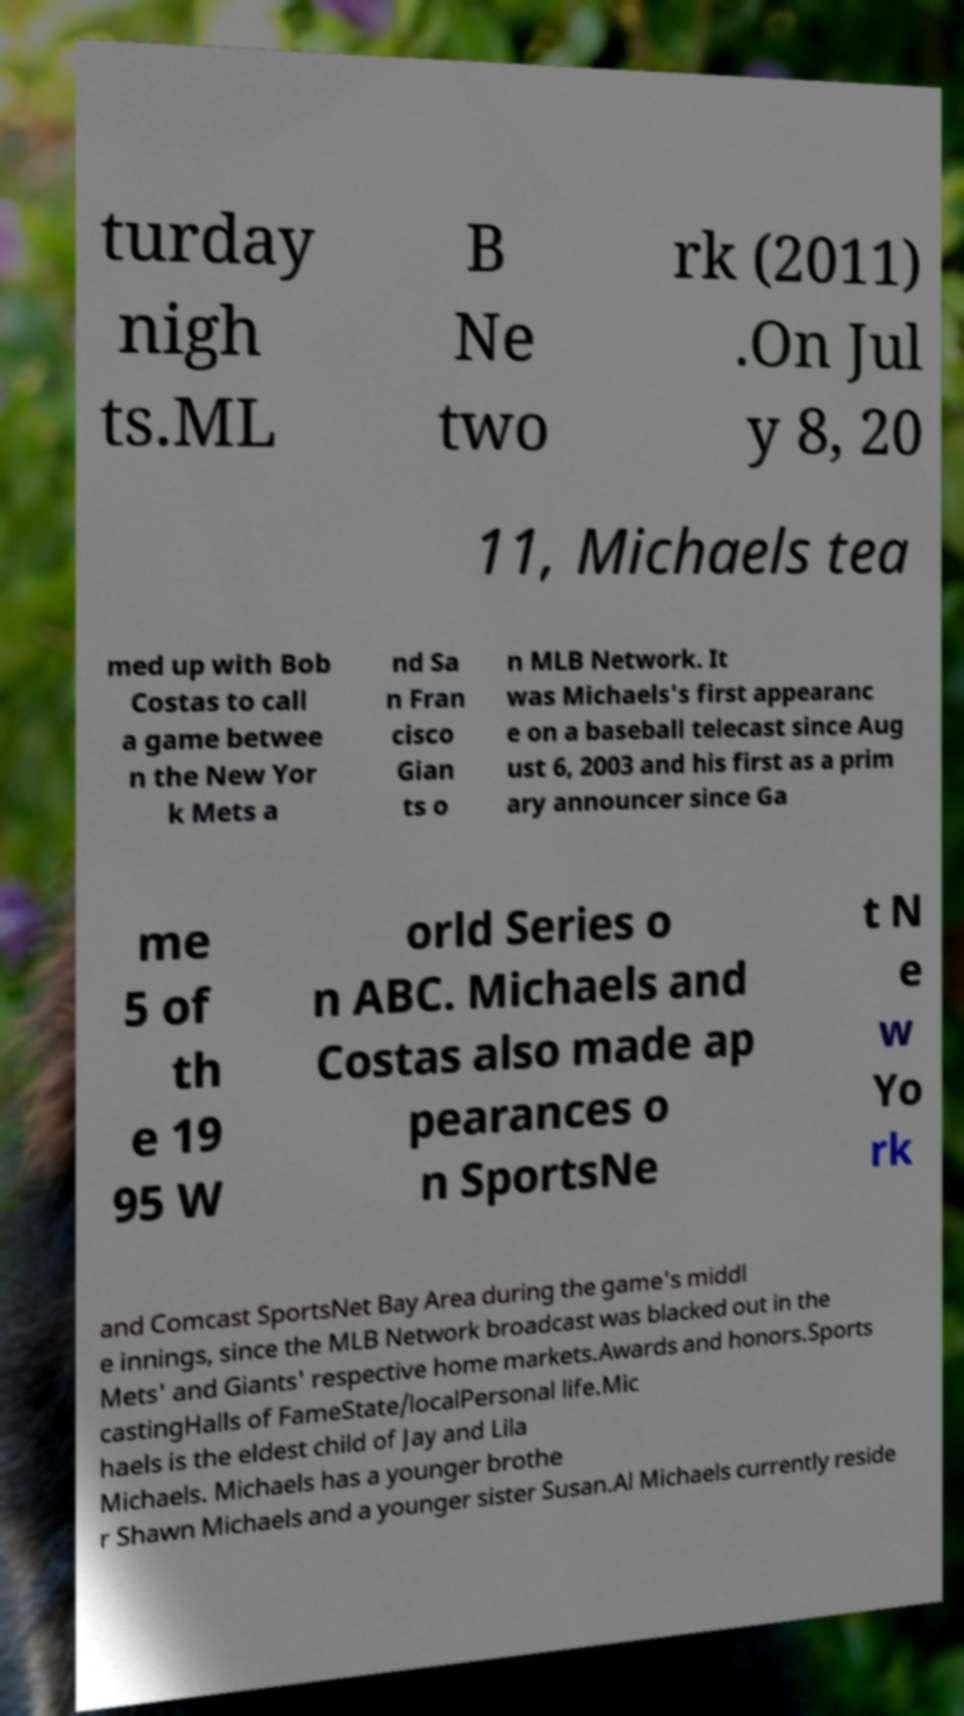Can you accurately transcribe the text from the provided image for me? turday nigh ts.ML B Ne two rk (2011) .On Jul y 8, 20 11, Michaels tea med up with Bob Costas to call a game betwee n the New Yor k Mets a nd Sa n Fran cisco Gian ts o n MLB Network. It was Michaels's first appearanc e on a baseball telecast since Aug ust 6, 2003 and his first as a prim ary announcer since Ga me 5 of th e 19 95 W orld Series o n ABC. Michaels and Costas also made ap pearances o n SportsNe t N e w Yo rk and Comcast SportsNet Bay Area during the game's middl e innings, since the MLB Network broadcast was blacked out in the Mets' and Giants' respective home markets.Awards and honors.Sports castingHalls of FameState/localPersonal life.Mic haels is the eldest child of Jay and Lila Michaels. Michaels has a younger brothe r Shawn Michaels and a younger sister Susan.Al Michaels currently reside 